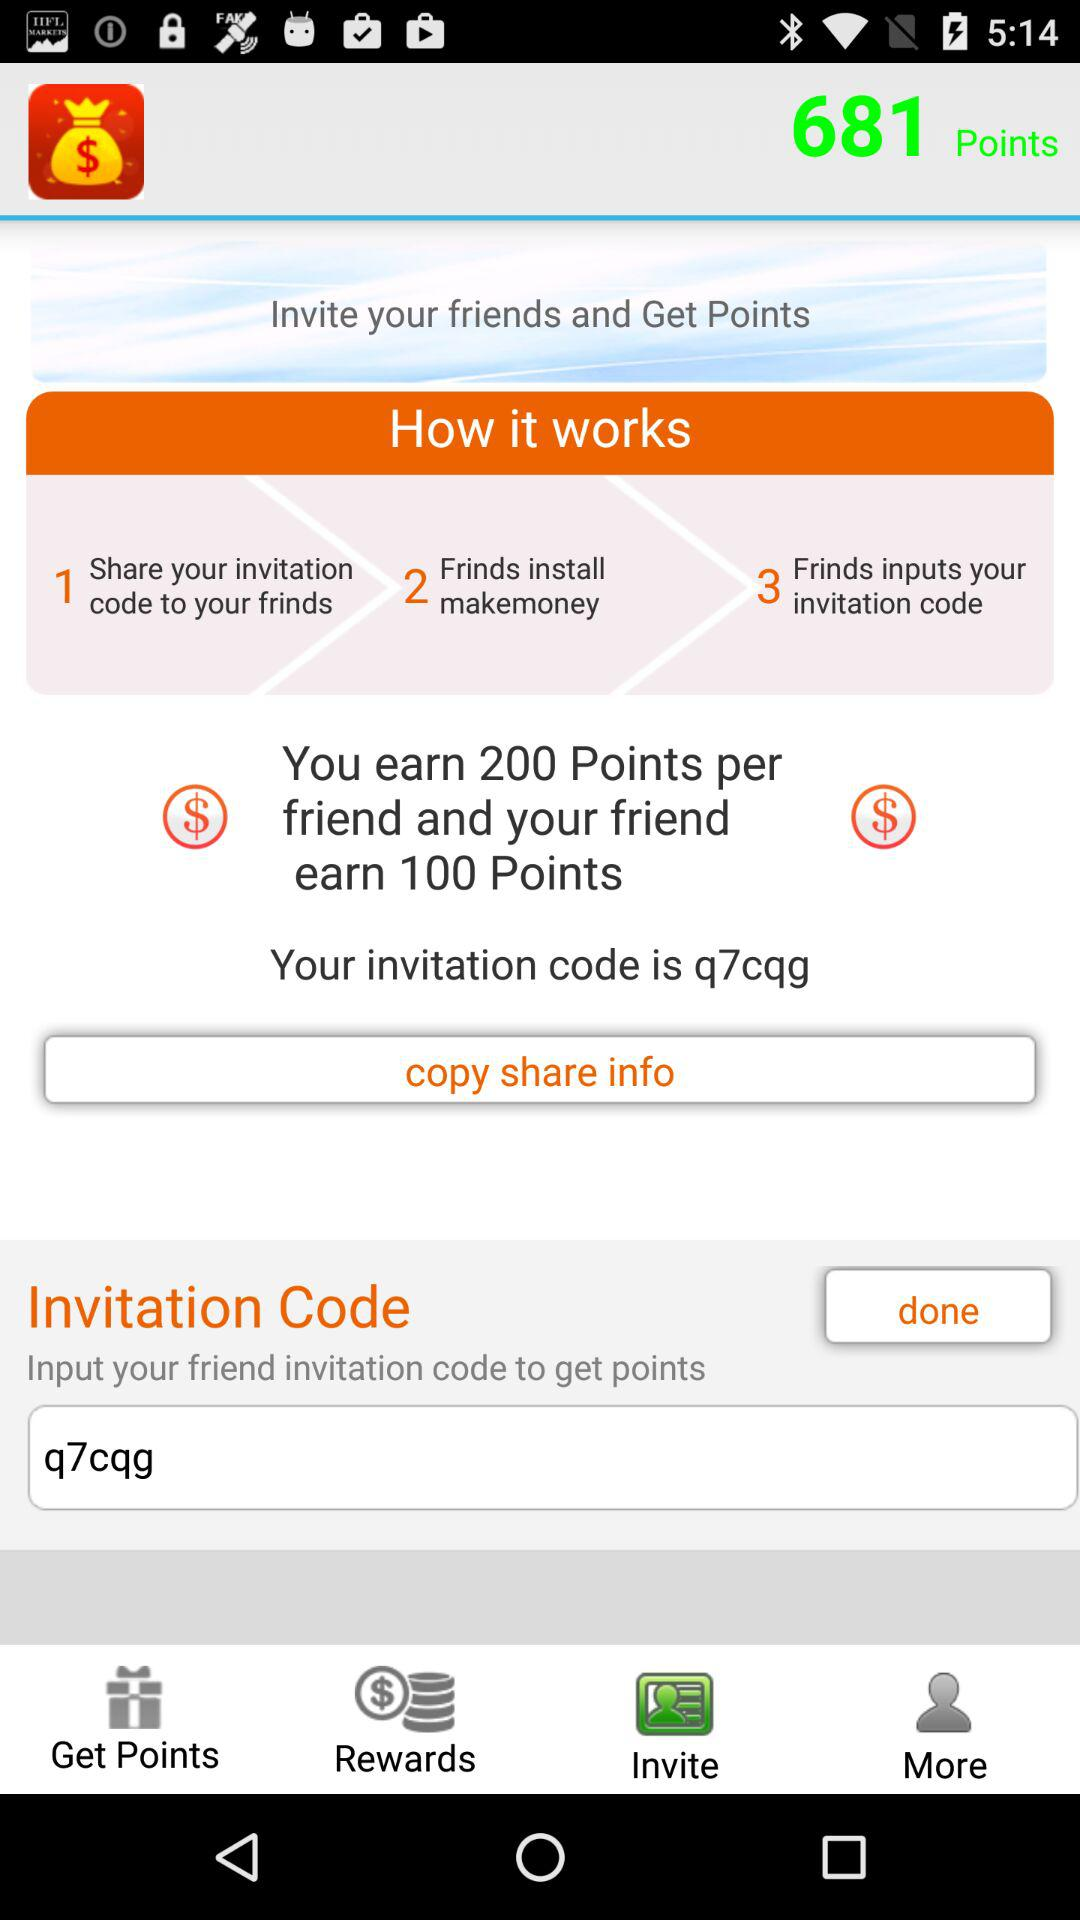How many points are shown? The shown points are 681. 